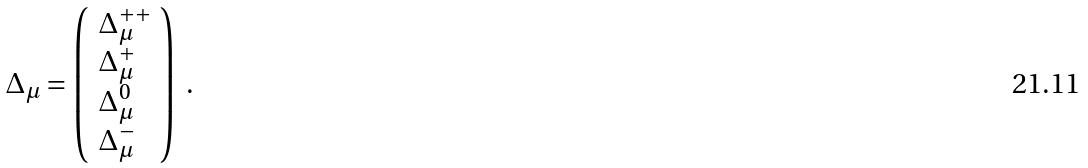<formula> <loc_0><loc_0><loc_500><loc_500>\Delta _ { \mu } = \left ( \begin{array} { l } \Delta _ { \mu } ^ { + + } \\ \Delta _ { \mu } ^ { + } \\ \Delta _ { \mu } ^ { 0 } \\ \Delta _ { \mu } ^ { - } \end{array} \right ) \ .</formula> 